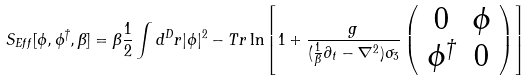<formula> <loc_0><loc_0><loc_500><loc_500>S _ { E f f } [ \phi , \phi ^ { \dagger } , \beta ] = \beta \frac { 1 } { 2 } \int d ^ { D } r | \phi | ^ { 2 } - T r \ln \left [ 1 + \frac { g } { ( \frac { 1 } { \beta } \partial _ { t } - \nabla ^ { 2 } ) \sigma _ { 3 } } \left ( \begin{array} { c c } 0 & \phi \\ \phi ^ { \dagger } & 0 \end{array} \right ) \right ]</formula> 